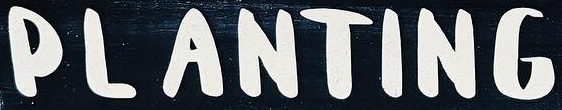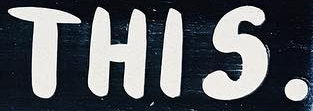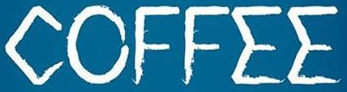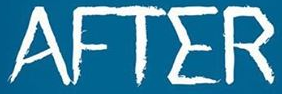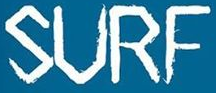What text appears in these images from left to right, separated by a semicolon? PLANTING; THIS.; COFFEE; AFTER; SURF 